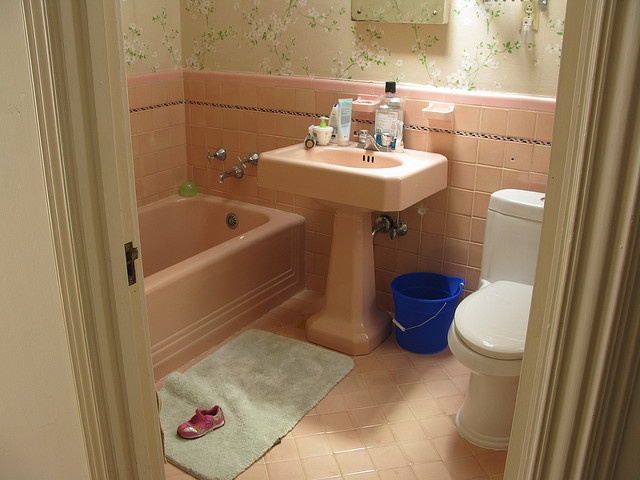Describe the objects in this image and their specific colors. I can see sink in gray, brown, and tan tones, toilet in gray, darkgray, lightgray, and tan tones, bottle in gray, tan, darkgray, and lightgray tones, and bottle in gray and tan tones in this image. 